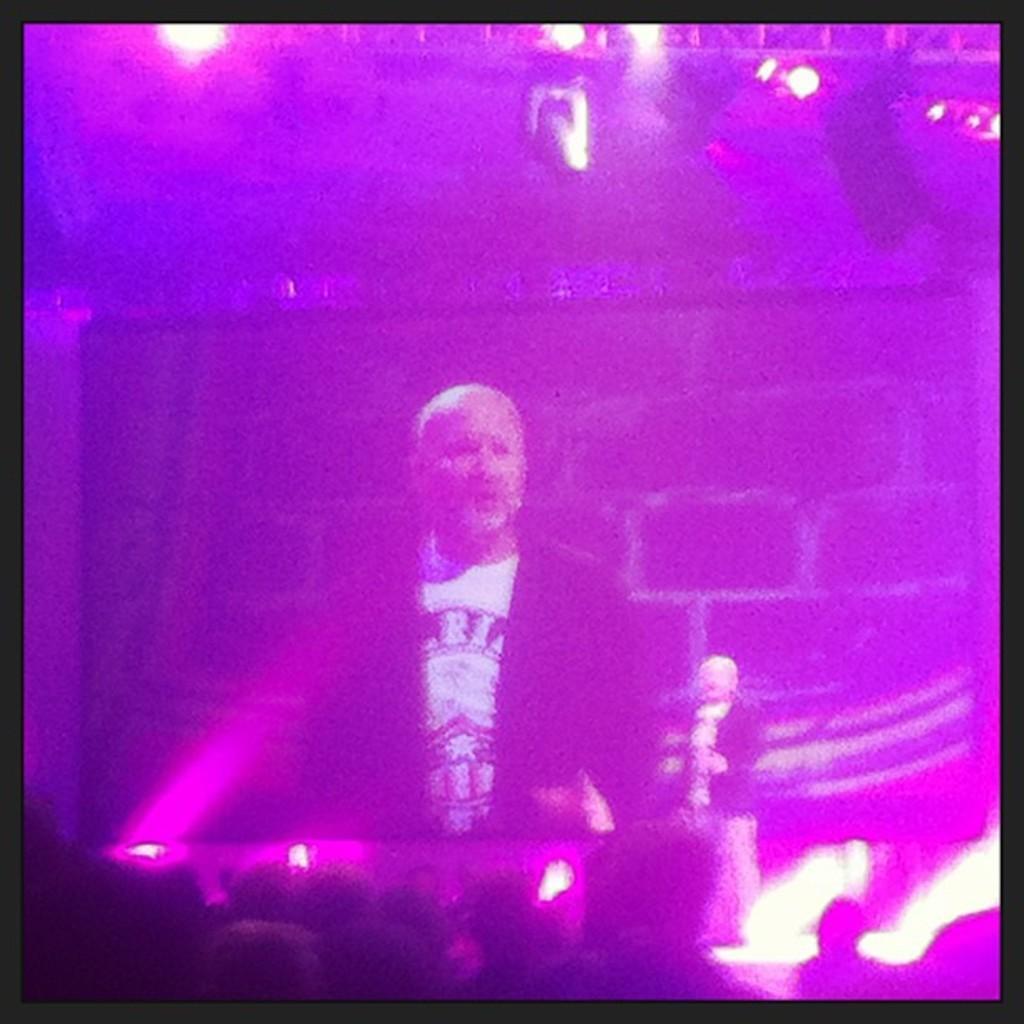How would you summarize this image in a sentence or two? In this image I can see a person standing wearing white color shirt and I can see few colorful lights. 